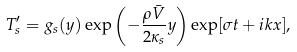Convert formula to latex. <formula><loc_0><loc_0><loc_500><loc_500>T ^ { \prime } _ { s } = g _ { s } ( y ) \exp \left ( - \frac { \rho \bar { V } } { 2 \kappa _ { s } } y \right ) \exp [ \sigma t + i k x ] ,</formula> 